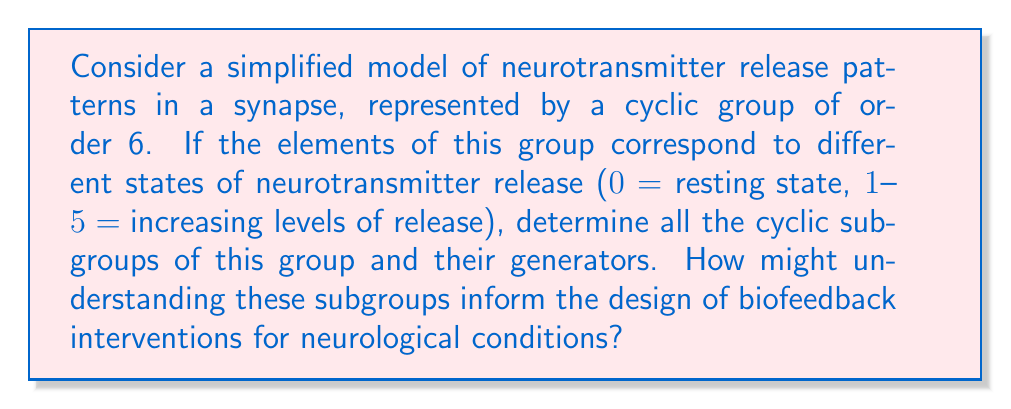Could you help me with this problem? To solve this problem, we need to follow these steps:

1) First, let's define our group. We have a cyclic group of order 6, which we can represent as $\mathbb{Z}_6$ or $\{0, 1, 2, 3, 4, 5\}$ under addition modulo 6.

2) To find all cyclic subgroups, we need to consider each element of the group and determine the subgroup it generates:

   a) $\langle 0 \rangle = \{0\}$ (trivial subgroup)
   b) $\langle 1 \rangle = \{0, 1, 2, 3, 4, 5\}$ (the entire group)
   c) $\langle 2 \rangle = \{0, 2, 4\}$
   d) $\langle 3 \rangle = \{0, 3\}$
   e) $\langle 4 \rangle = \{0, 2, 4\}$ (same as $\langle 2 \rangle$)
   f) $\langle 5 \rangle = \{0, 1, 2, 3, 4, 5\}$ (same as $\langle 1 \rangle$)

3) Therefore, the distinct cyclic subgroups are:
   - $\{0\}$ (order 1)
   - $\{0, 3\}$ (order 2)
   - $\{0, 2, 4\}$ (order 3)
   - $\{0, 1, 2, 3, 4, 5\}$ (order 6)

4) The generators for each subgroup are:
   - $\{0\}$: 0
   - $\{0, 3\}$: 3
   - $\{0, 2, 4\}$: 2 and 4
   - $\{0, 1, 2, 3, 4, 5\}$: 1 and 5

5) In the context of neurotransmitter release patterns, these subgroups could represent different cyclic patterns of release:
   - $\{0\}$: constant resting state
   - $\{0, 3\}$: alternating between resting state and moderate release
   - $\{0, 2, 4\}$: cycling through resting state and two levels of release
   - $\{0, 1, 2, 3, 4, 5\}$: full cycle of all release states

Understanding these subgroups could inform biofeedback interventions by:
- Identifying stable patterns of neurotransmitter release
- Designing interventions to shift from one subgroup pattern to another
- Targeting specific generators to influence the entire release cycle
Answer: The cyclic subgroups of $\mathbb{Z}_6$ are:
1) $\{0\}$ with generator 0
2) $\{0, 3\}$ with generator 3
3) $\{0, 2, 4\}$ with generators 2 and 4
4) $\{0, 1, 2, 3, 4, 5\}$ with generators 1 and 5

These subgroups represent different cyclic patterns of neurotransmitter release, which could be targeted in biofeedback interventions for neurological conditions. 